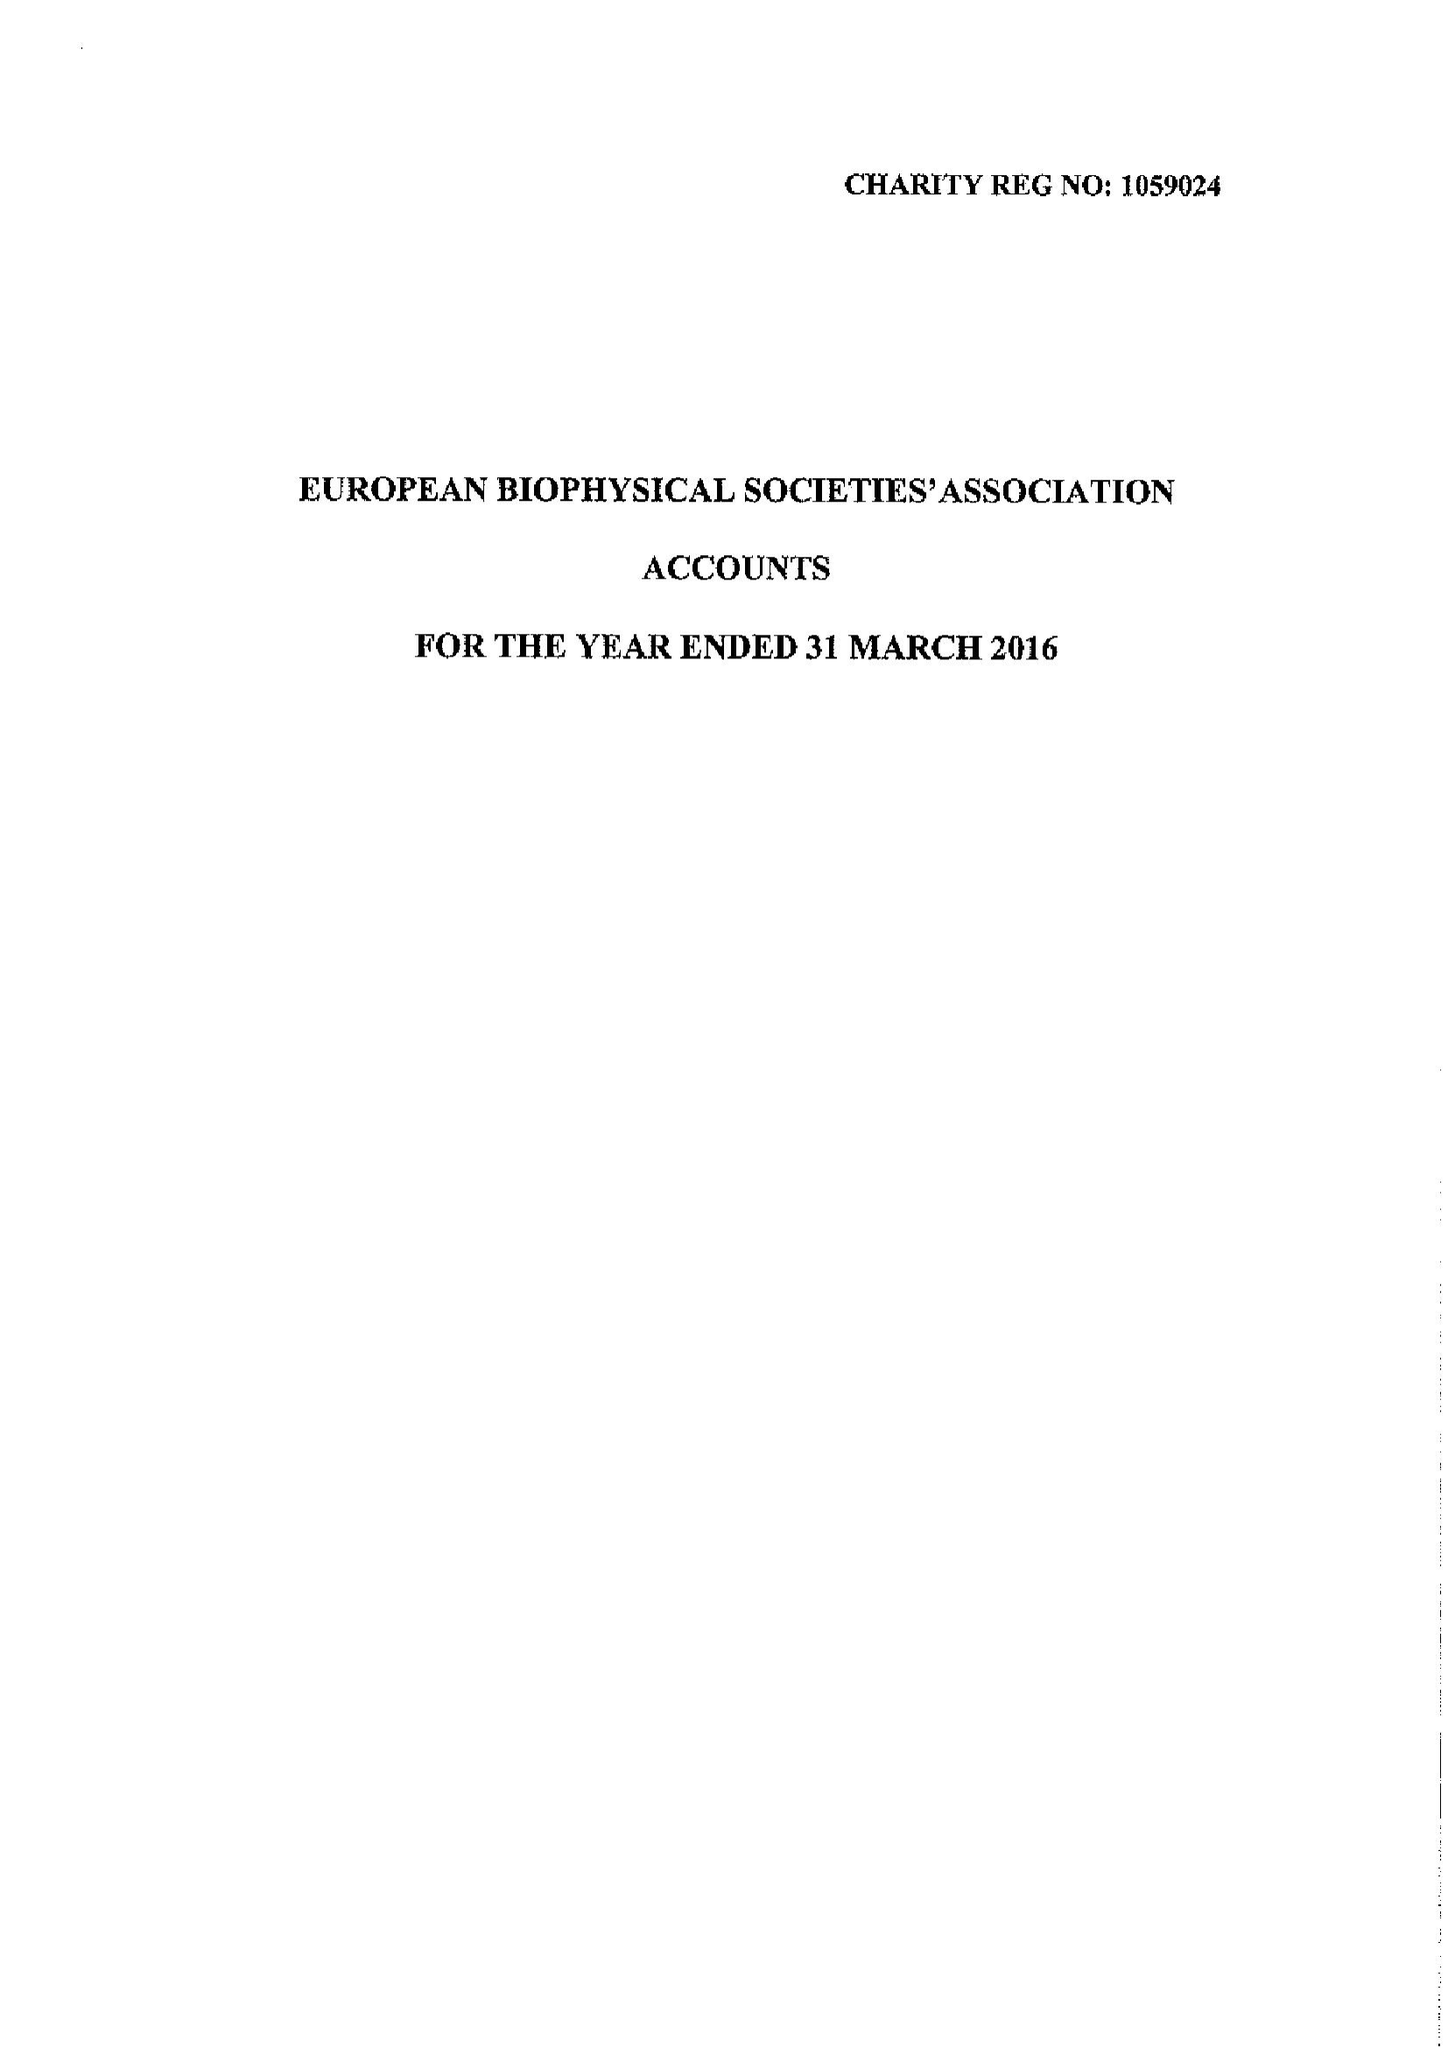What is the value for the address__street_line?
Answer the question using a single word or phrase. None 